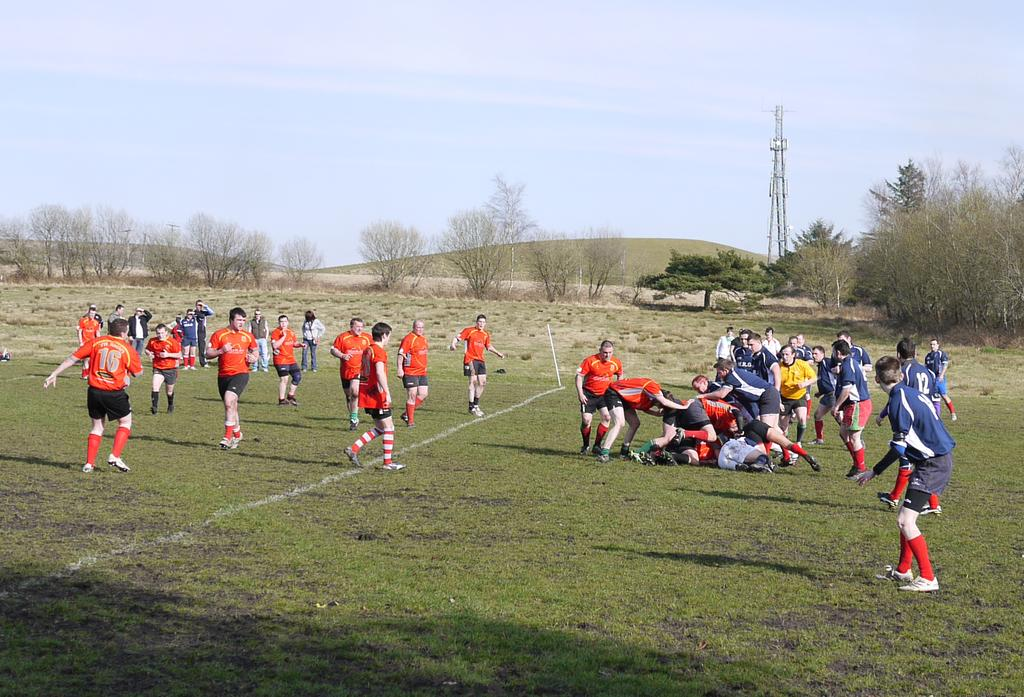Who is present in the image? There are people in the image. What are the people wearing? The people are wearing jerseys. How many teams are visible in the image? There are two teams in the image. Where is the setting of the image? The setting is a playground. What type of curve can be seen in the image? There is no curve present in the image; it features people wearing jerseys and playing on a playground. 